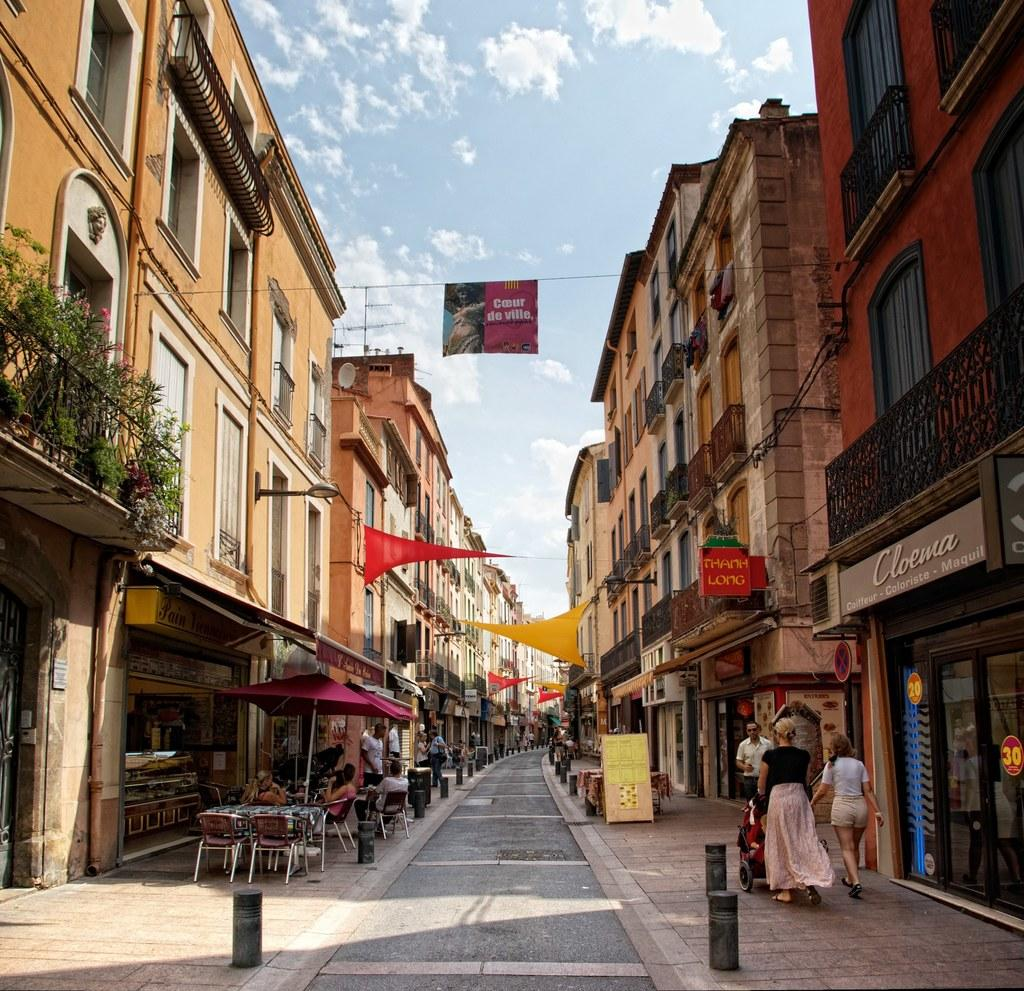What type of structures can be seen in the image? There are buildings in the image. Who or what else is present in the image? There are people and safety poles visible in the image. What type of furniture is in the image? There are chairs in the image. What is the setting of the image? There is a roadside in the image. What type of vegetation is present in the image? There are plants in the image. What message or information is conveyed by the banner in the image? The banner in the image has some text, but we cannot determine the specific message without more information. What is visible at the top of the image? The sky is visible at the top of the image, and there are clouds in the sky. What type of spoon is being used to measure the growth of the plants in the image? There is no spoon present in the image, and the growth of the plants cannot be determined from the image alone. 